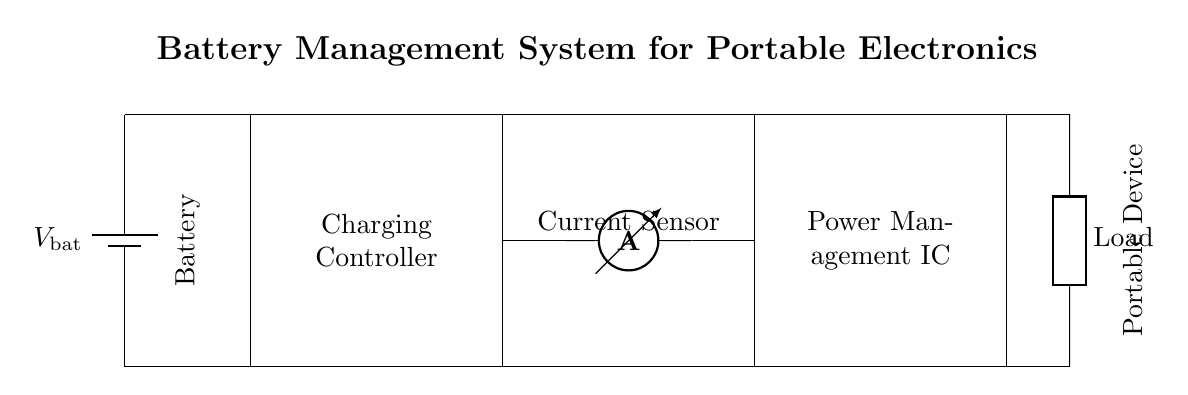What component is used to manage the charging process? The component responsible for managing the charging process is marked as "Charging Controller" in the diagram. It is crucial for regulating the flow of current to charge the battery effectively.
Answer: Charging Controller What is the function of the current sensor? The current sensor is indicated as "Current Sensor" in the circuit and is responsible for measuring the current flowing through the circuit. This measurement is necessary for monitoring and controlling the charging process to avoid overcharging.
Answer: Current Sensor What type of load is depicted in the circuit? The load in the circuit is labeled as "Load." It indicates that this is a generic component representing the device or application powered by the battery system, which could vary depending on specific use cases.
Answer: Load How many main components are visible in the diagram? There are five main components visible in the diagram: Battery, Charging Controller, Current Sensor, Power Management IC, and Load. Each component serves a distinct function within the battery management system.
Answer: Five What is the total voltage supplied by the battery? The total voltage supplied by the battery is denoted as "V_bat." While the specific voltage is not given in the diagram, it indicates that this is the voltage source for the entire system, essential for charging and powering the load.
Answer: V_bat Which component directly interacts with the load? The component that directly interacts with the load, depicted on the right side of the circuit, is the "Power Management IC." This IC is responsible for supplying power to the load based on the battery's status and current requirements.
Answer: Power Management IC What is the role of the power management IC in this circuit? The Power Management IC is depicted in the circuit and is tasked with distributing the power appropriately from the battery to the load, while also ensuring that the voltage levels are within acceptable ranges and preventing overload.
Answer: Distributing power 